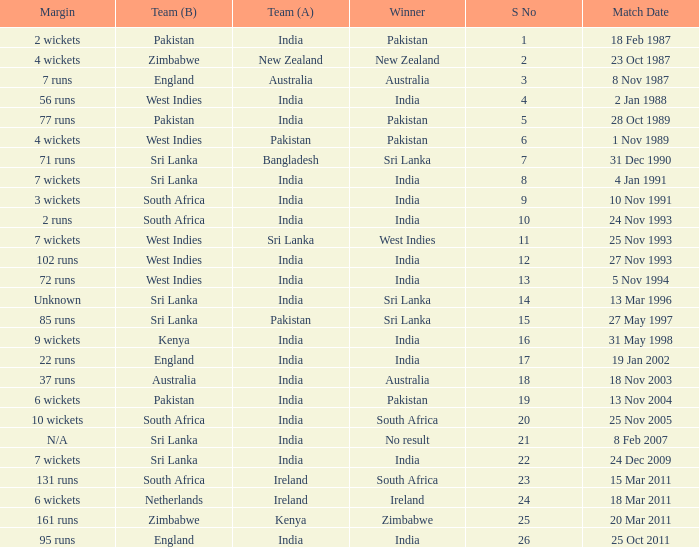What date did the West Indies win the match? 25 Nov 1993. 